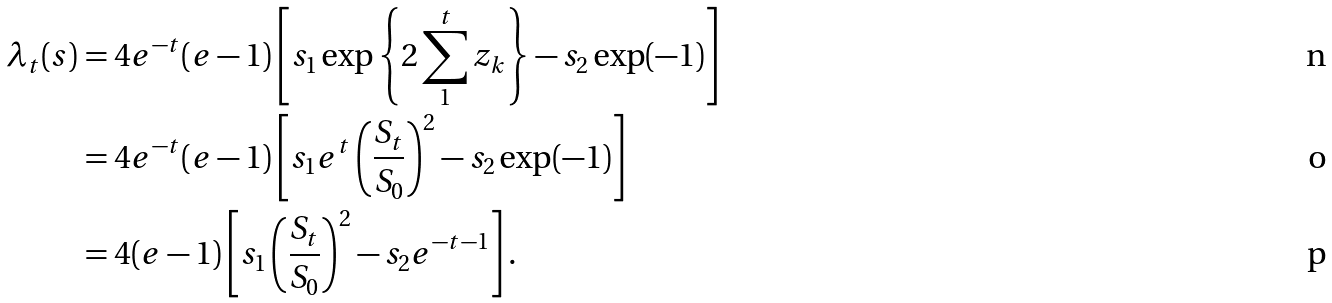<formula> <loc_0><loc_0><loc_500><loc_500>\lambda _ { t } ( s ) & = { 4 e ^ { - t } ( e - 1 ) } \left [ s _ { 1 } \exp \left \{ 2 \sum _ { 1 } ^ { t } z _ { k } \right \} - s _ { 2 } \exp ( - 1 ) \right ] \\ & = { 4 e ^ { - t } ( e - 1 ) } \left [ s _ { 1 } e ^ { t } \left ( \frac { S _ { t } } { S _ { 0 } } \right ) ^ { 2 } - s _ { 2 } \exp ( - 1 ) \right ] \\ & = 4 ( e - 1 ) \left [ { s _ { 1 } } \left ( \frac { S _ { t } } { S _ { 0 } } \right ) ^ { 2 } - { s _ { 2 } } e ^ { - t - 1 } \right ] .</formula> 